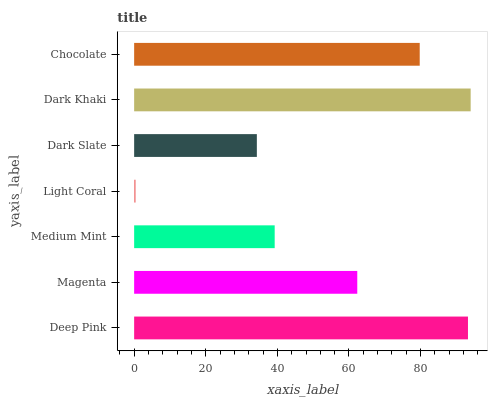Is Light Coral the minimum?
Answer yes or no. Yes. Is Dark Khaki the maximum?
Answer yes or no. Yes. Is Magenta the minimum?
Answer yes or no. No. Is Magenta the maximum?
Answer yes or no. No. Is Deep Pink greater than Magenta?
Answer yes or no. Yes. Is Magenta less than Deep Pink?
Answer yes or no. Yes. Is Magenta greater than Deep Pink?
Answer yes or no. No. Is Deep Pink less than Magenta?
Answer yes or no. No. Is Magenta the high median?
Answer yes or no. Yes. Is Magenta the low median?
Answer yes or no. Yes. Is Deep Pink the high median?
Answer yes or no. No. Is Chocolate the low median?
Answer yes or no. No. 